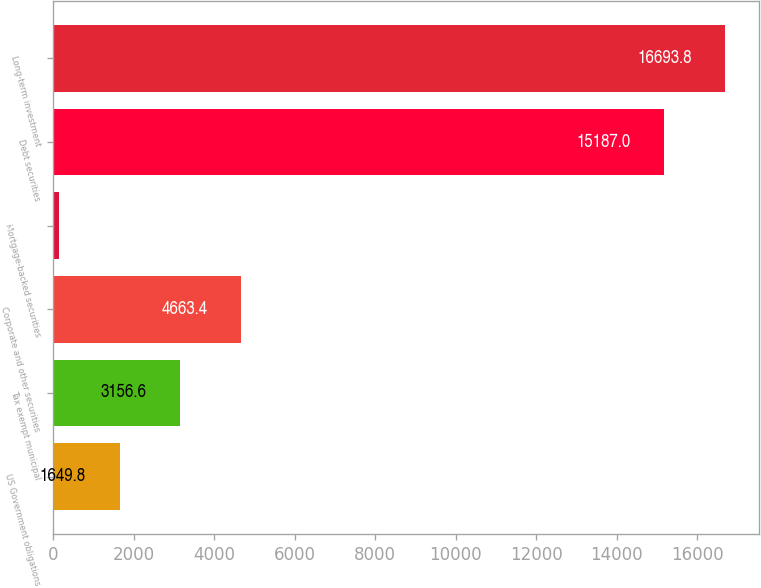Convert chart to OTSL. <chart><loc_0><loc_0><loc_500><loc_500><bar_chart><fcel>US Government obligations<fcel>Tax exempt municipal<fcel>Corporate and other securities<fcel>Mortgage-backed securities<fcel>Debt securities<fcel>Long-term investment<nl><fcel>1649.8<fcel>3156.6<fcel>4663.4<fcel>143<fcel>15187<fcel>16693.8<nl></chart> 